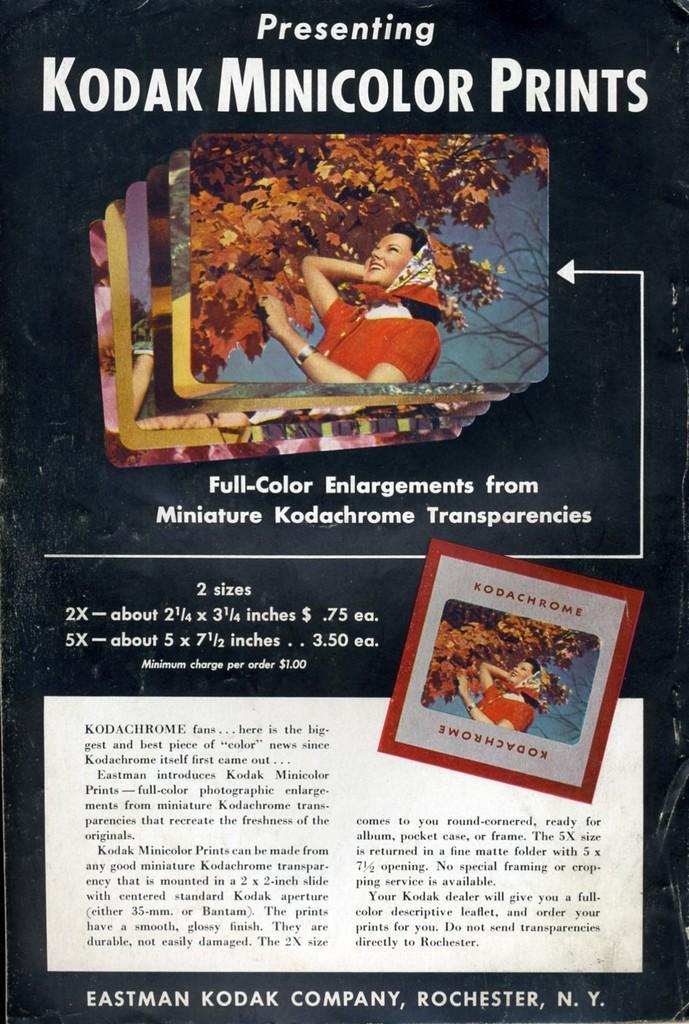Could you give a brief overview of what you see in this image? In this image, we can see a flyer contains pictures and some text. 